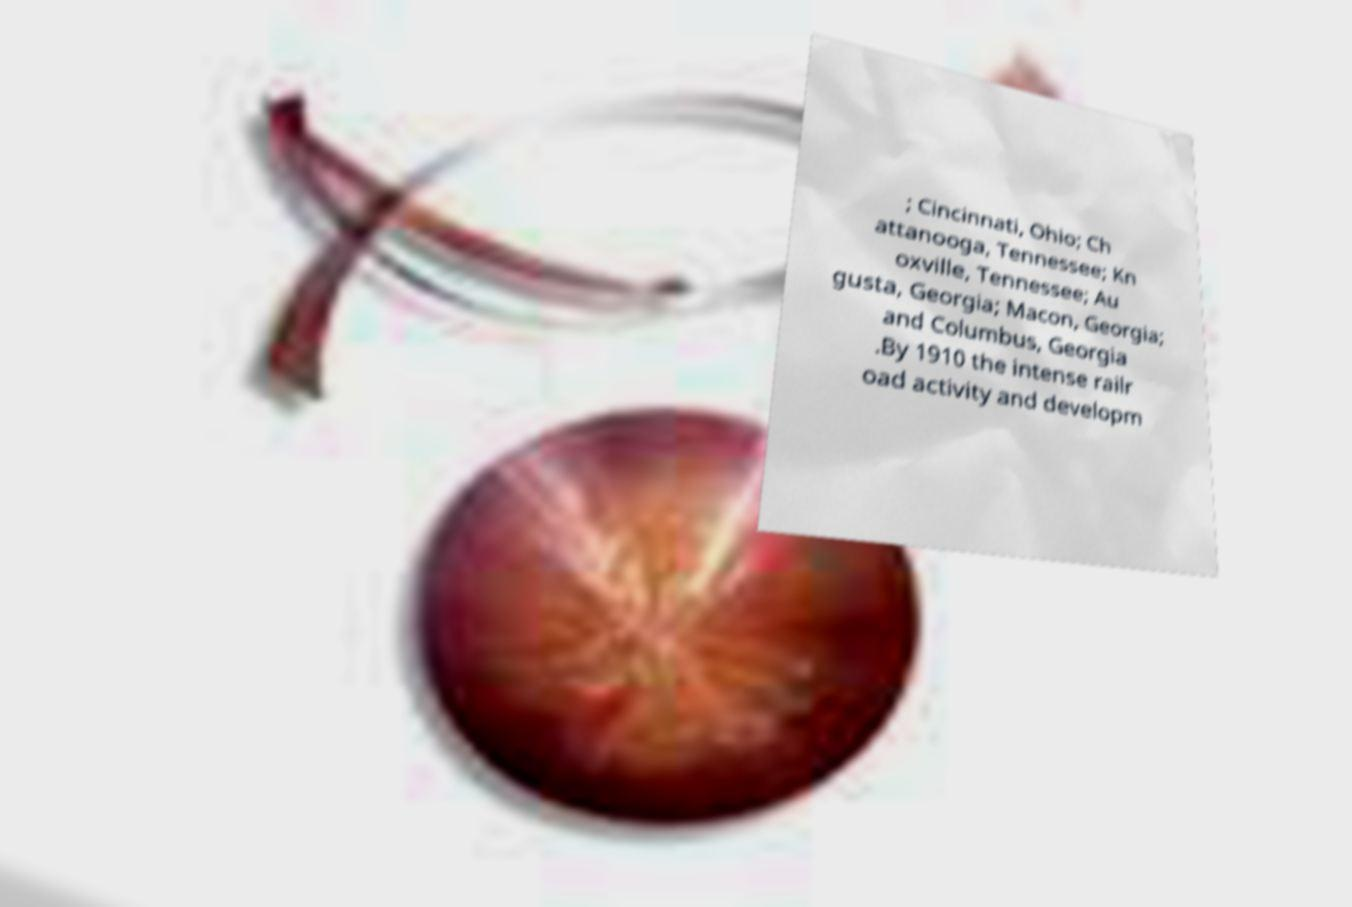There's text embedded in this image that I need extracted. Can you transcribe it verbatim? ; Cincinnati, Ohio; Ch attanooga, Tennessee; Kn oxville, Tennessee; Au gusta, Georgia; Macon, Georgia; and Columbus, Georgia .By 1910 the intense railr oad activity and developm 